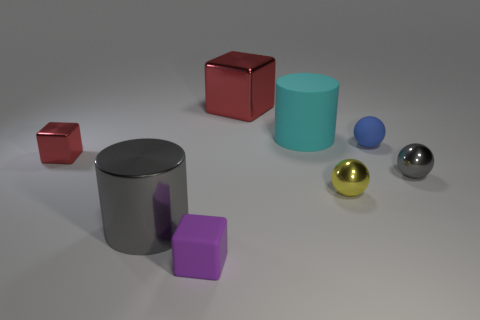Does the gray thing that is to the left of the rubber block have the same size as the purple rubber object to the left of the cyan rubber cylinder?
Offer a terse response. No. There is a gray object that is on the right side of the blue object; what shape is it?
Give a very brief answer. Sphere. What color is the large shiny cube?
Your answer should be compact. Red. Is the size of the yellow sphere the same as the cylinder in front of the large rubber cylinder?
Ensure brevity in your answer.  No. What number of rubber objects are either big gray cylinders or gray balls?
Your answer should be compact. 0. Is the color of the large matte thing the same as the cylinder in front of the small blue rubber object?
Your answer should be compact. No. What shape is the tiny purple matte object?
Offer a very short reply. Cube. There is a red thing that is behind the tiny matte thing that is right of the red cube that is to the right of the rubber block; what is its size?
Your response must be concise. Large. What number of other objects are the same shape as the tiny purple object?
Offer a very short reply. 2. Does the large object to the left of the large cube have the same shape as the red metallic object that is behind the cyan object?
Your answer should be compact. No. 